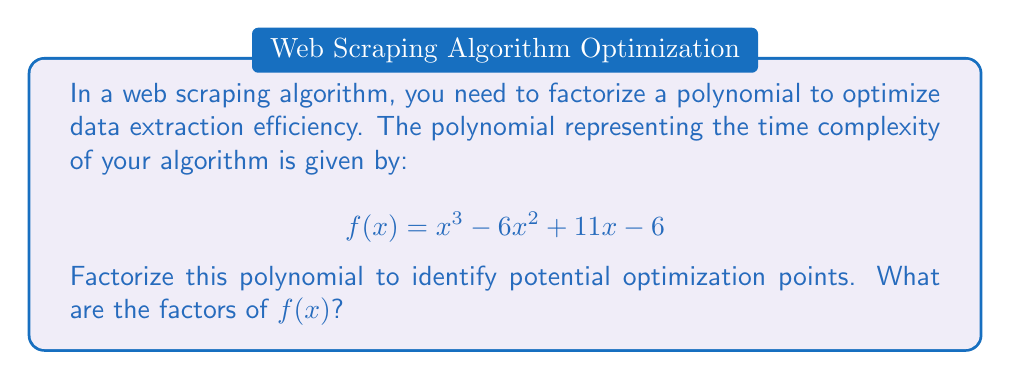Could you help me with this problem? To factorize this cubic polynomial, we'll follow these steps:

1) First, let's check if there are any rational roots using the rational root theorem. The possible rational roots are the factors of the constant term (6): ±1, ±2, ±3, ±6.

2) Testing these values, we find that $f(1) = 0$. So $(x-1)$ is a factor.

3) We can use polynomial long division to divide $f(x)$ by $(x-1)$:

   $$\frac{x^3 - 6x^2 + 11x - 6}{x-1} = x^2 - 5x + 6$$

4) Now we have: $f(x) = (x-1)(x^2 - 5x + 6)$

5) The quadratic factor $x^2 - 5x + 6$ can be factored further using the quadratic formula or by inspection. Its roots are 2 and 3.

6) Therefore, $x^2 - 5x + 6 = (x-2)(x-3)$

7) Combining all factors, we get:

   $$f(x) = (x-1)(x-2)(x-3)$$

This factorization reveals that the polynomial has three linear factors, corresponding to three distinct real roots: 1, 2, and 3.
Answer: $f(x) = (x-1)(x-2)(x-3)$ 